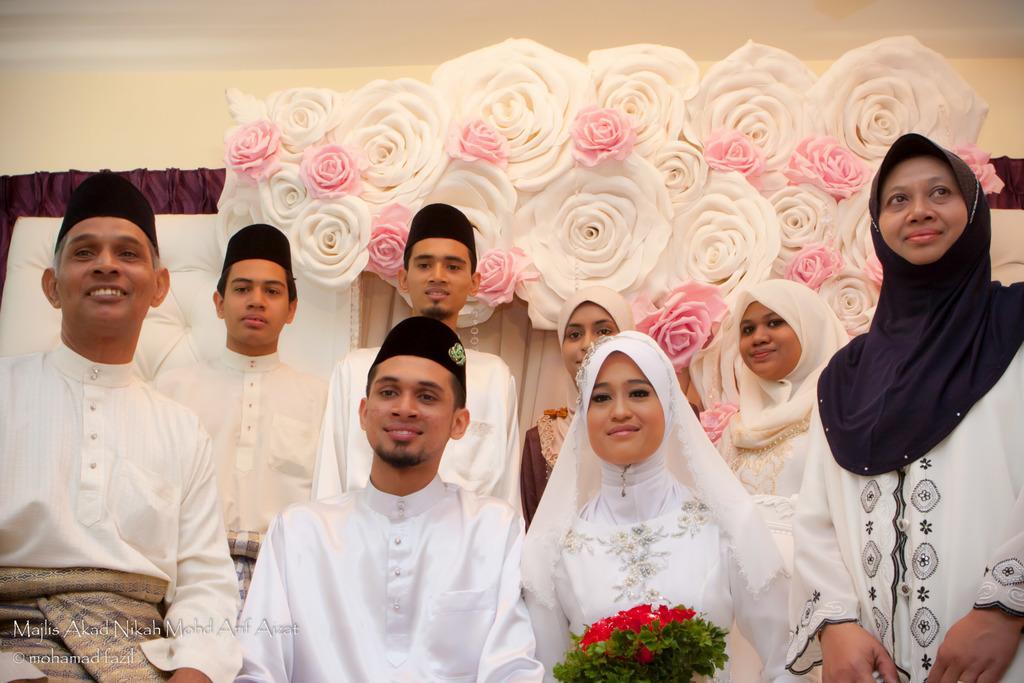Please provide a concise description of this image. In this picture we can see some people in the front, a woman in the middle is holding a flower bouquet, in the background there are some flowers, on the left side there is a curtain, there is some text at the left bottom of the image. 